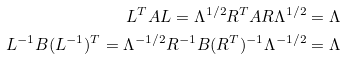<formula> <loc_0><loc_0><loc_500><loc_500>L ^ { T } A L = \Lambda ^ { 1 / 2 } R ^ { T } A R \Lambda ^ { 1 / 2 } = \Lambda \\ L ^ { - 1 } B ( L ^ { - 1 } ) ^ { T } = \Lambda ^ { - 1 / 2 } R ^ { - 1 } B ( R ^ { T } ) ^ { - 1 } \Lambda ^ { - 1 / 2 } = \Lambda</formula> 